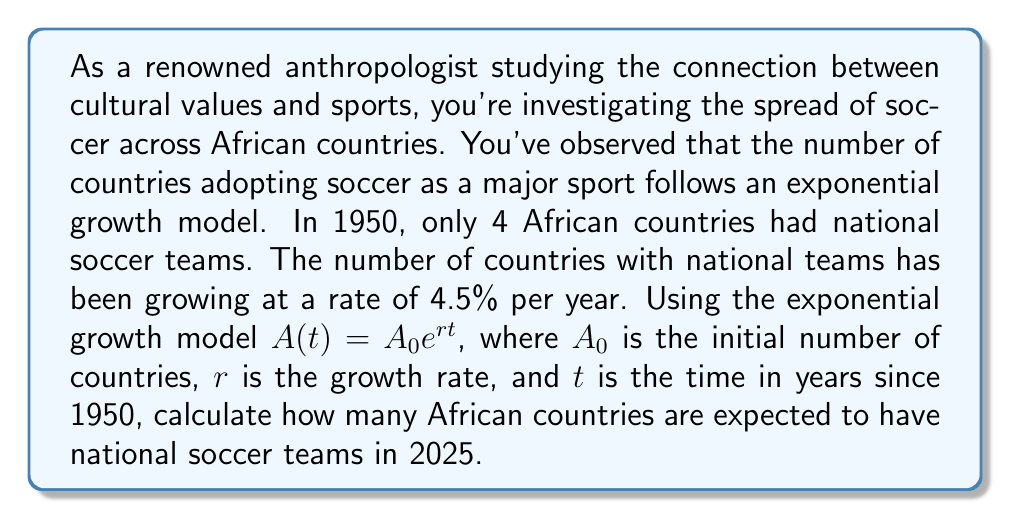Solve this math problem. To solve this problem, we'll use the exponential growth model:

$A(t) = A_0 e^{rt}$

Where:
$A(t)$ = Number of countries with national soccer teams after time $t$
$A_0$ = Initial number of countries (4 in 1950)
$r$ = Growth rate (4.5% = 0.045 per year)
$t$ = Time in years since 1950

We need to find $A(t)$ for the year 2025, which is 75 years after 1950.

Step 1: Identify the values for our equation
$A_0 = 4$
$r = 0.045$
$t = 75$

Step 2: Plug these values into our exponential growth equation
$A(75) = 4 e^{0.045 \times 75}$

Step 3: Simplify the exponent
$A(75) = 4 e^{3.375}$

Step 4: Calculate the result
$A(75) = 4 \times 29.2278 = 116.9112$

Step 5: Round to the nearest whole number, as we can't have a fractional number of countries
$A(75) \approx 117$

Therefore, by 2025, we expect approximately 117 African countries to have national soccer teams.
Answer: 117 African countries 